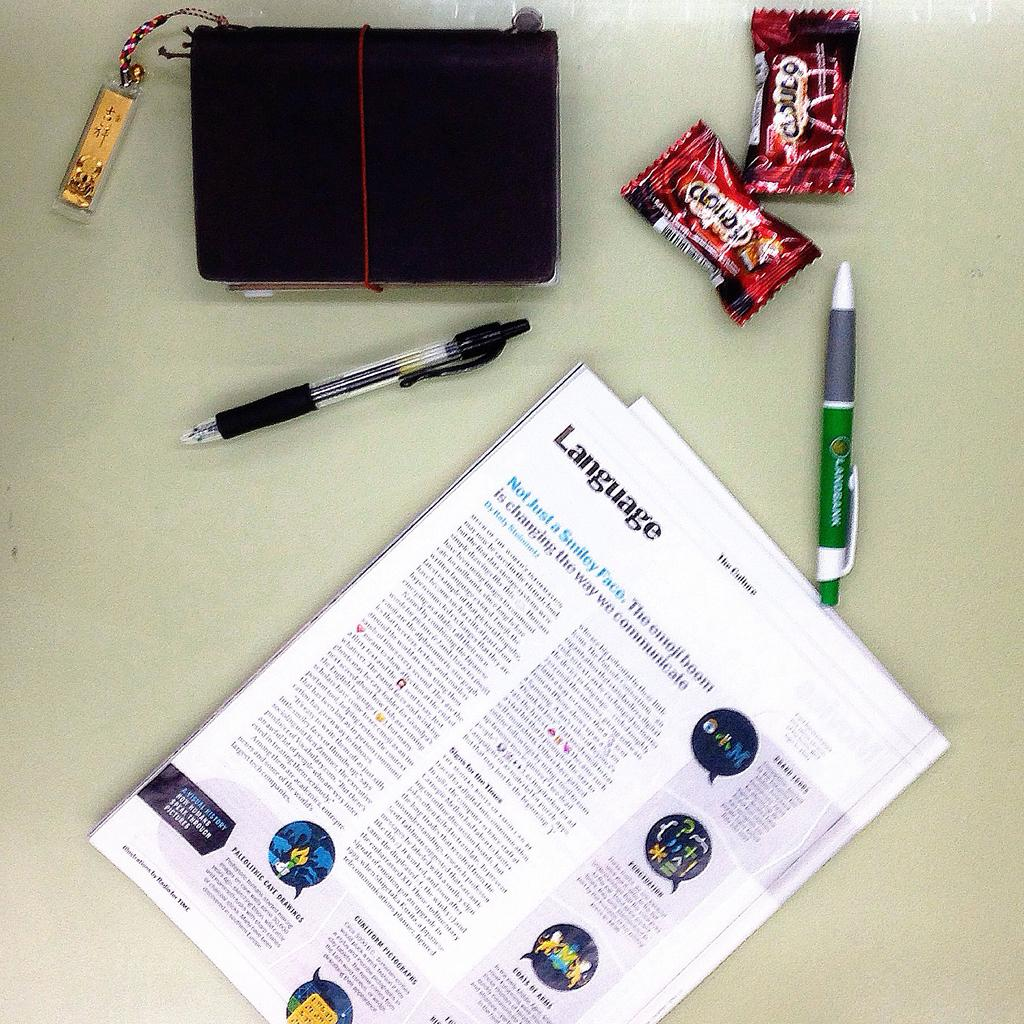What piece of furniture is present in the image? There is a table in the image. What items can be seen on the table? There are chocolates, pens, a bag, and papers on the table. What might be used for writing in the image? The pens on the table might be used for writing. What could be stored in the bag on the table? It is not possible to determine what is stored in the bag from the image. Where is the coat hanging in the image? There is no coat present in the image. How many arms are visible in the image? There are no arms visible in the image. 